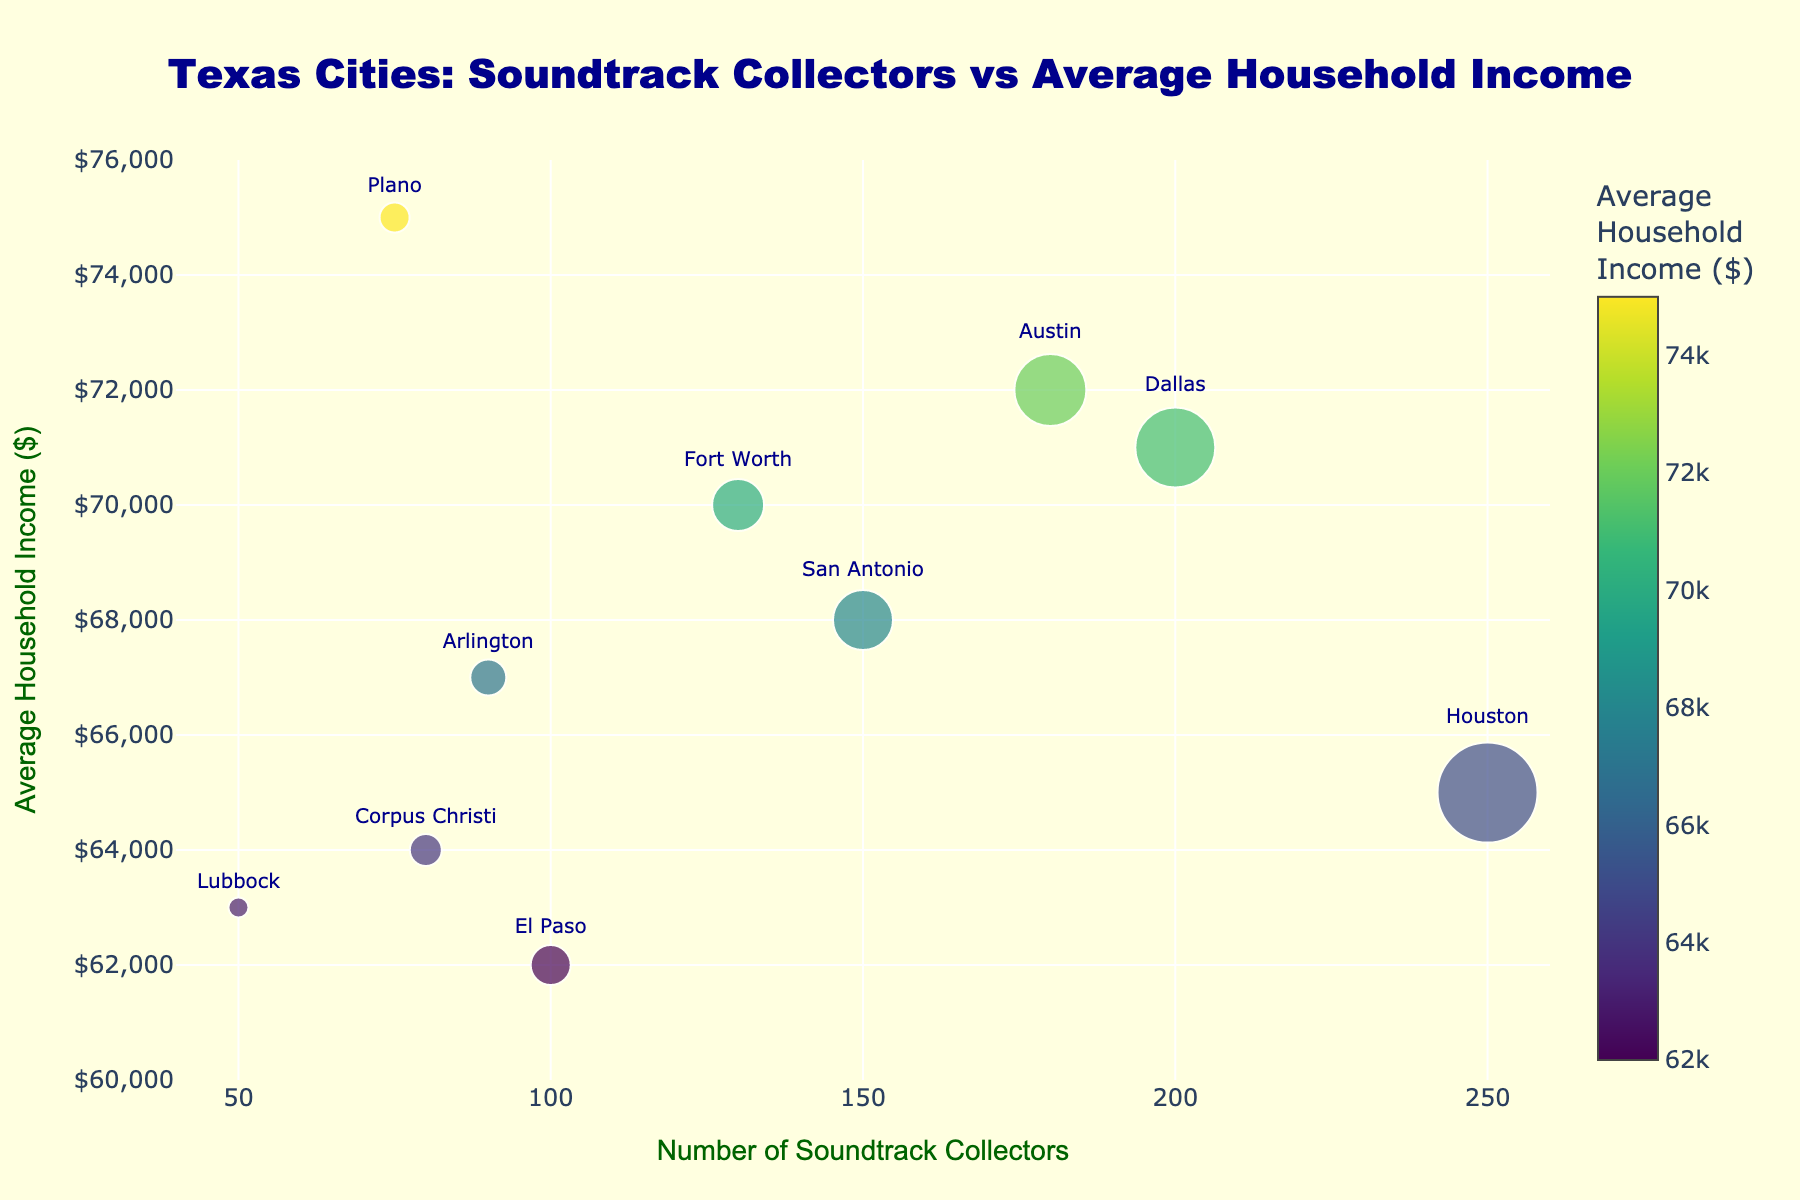What's the title of the plot? The title is displayed at the top center of the figure. It reads, "Texas Cities: Soundtrack Collectors vs Average Household Income".
Answer: Texas Cities: Soundtrack Collectors vs Average Household Income Which city has the highest number of soundtrack collectors? The data point at the far right on the x-axis represents Houston, labeled with 250 collectors.
Answer: Houston How many cities have an average household income above $70,000? Look at the data points above the $70,000 line on the y-axis. Dallas, Austin, Fort Worth, and Plano are the cities above this line.
Answer: 4 Which city has the lowest number of soundtrack collectors? The far left data point on the x-axis represents Lubbock, labeled with 50 collectors.
Answer: Lubbock What is the average household income for Dallas? Find the data point labeled "Dallas" and refer to its y-axis value. Dallas has an average household income of $71,000.
Answer: $71,000 How much more is the average household income in Plano than in El Paso? Plano's income is $75,000 and El Paso's is $62,000. Subtract El Paso's income from Plano's: $75,000 - $62,000 = $13,000.
Answer: $13,000 Is the number of soundtrack collectors proportional to average household income? By observing the scatter plot, the number of collectors does not show a clear linear relationship with household income, as cities with high collectors do not necessarily have proportionally higher incomes.
Answer: No Compare the average household income of Austin to Arlington. Which is higher, and by how much? Austin's income is $72,000, while Arlington's is $67,000. The difference is $72,000 - $67,000 = $5,000.
Answer: Austin, by $5,000 Which city with fewer than 100 soundtrack collectors has the highest average household income? Among the cities with fewer than 100 collectors (El Paso, Arlington, Corpus Christi, Plano, and Lubbock), Plano has the highest average household income of $75,000.
Answer: Plano How many cities have between 50 and 150 soundtrack collectors, and what are they? Look at the data points between 50 and 150 on the x-axis. There are Corpus Christi, Plano, and Lubbock.
Answer: 3, Corpus Christi, Plano, Lubbock 